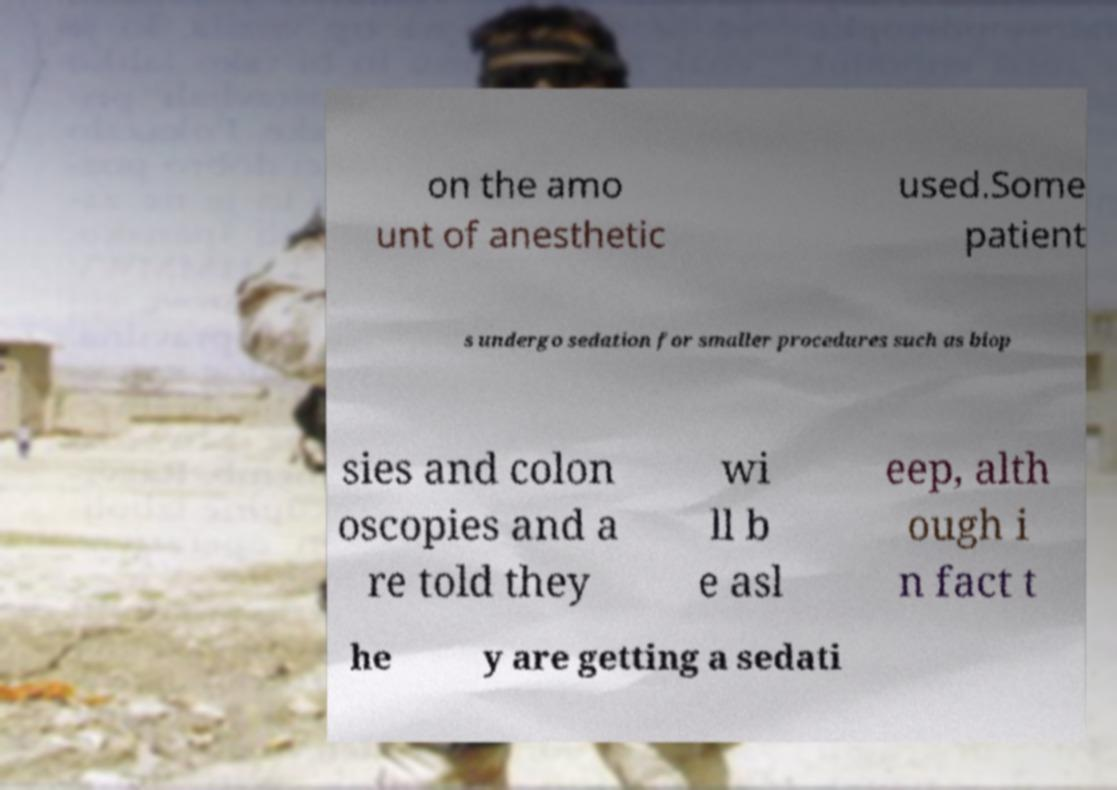For documentation purposes, I need the text within this image transcribed. Could you provide that? on the amo unt of anesthetic used.Some patient s undergo sedation for smaller procedures such as biop sies and colon oscopies and a re told they wi ll b e asl eep, alth ough i n fact t he y are getting a sedati 